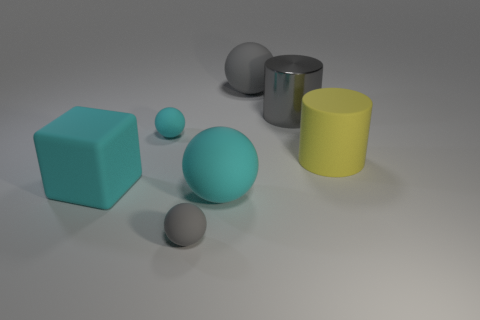Are there more large objects on the right side of the small cyan rubber sphere than matte cylinders?
Your answer should be very brief. Yes. What number of other things are made of the same material as the large yellow thing?
Your answer should be very brief. 5. What number of large objects are either green objects or gray objects?
Your answer should be very brief. 2. Is the small cyan thing made of the same material as the large gray cylinder?
Offer a very short reply. No. How many rubber blocks are on the right side of the ball behind the gray metallic cylinder?
Give a very brief answer. 0. Are there any gray rubber things that have the same shape as the tiny cyan matte object?
Offer a terse response. Yes. Is the shape of the gray rubber object to the right of the big cyan matte sphere the same as the gray matte thing that is in front of the gray metallic cylinder?
Offer a terse response. Yes. The cyan matte thing that is both left of the big cyan rubber sphere and right of the block has what shape?
Your answer should be very brief. Sphere. Are there any brown rubber blocks that have the same size as the gray metal cylinder?
Ensure brevity in your answer.  No. Do the large matte cube and the big rubber ball that is in front of the big metallic cylinder have the same color?
Your response must be concise. Yes. 